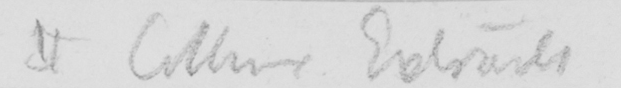What does this handwritten line say? II Collins Extracts 